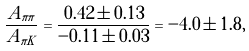Convert formula to latex. <formula><loc_0><loc_0><loc_500><loc_500>\frac { A _ { \pi \pi } } { A _ { \pi K } } = \frac { 0 . 4 2 \pm 0 . 1 3 } { - 0 . 1 1 \pm 0 . 0 3 } = - 4 . 0 \pm 1 . 8 ,</formula> 